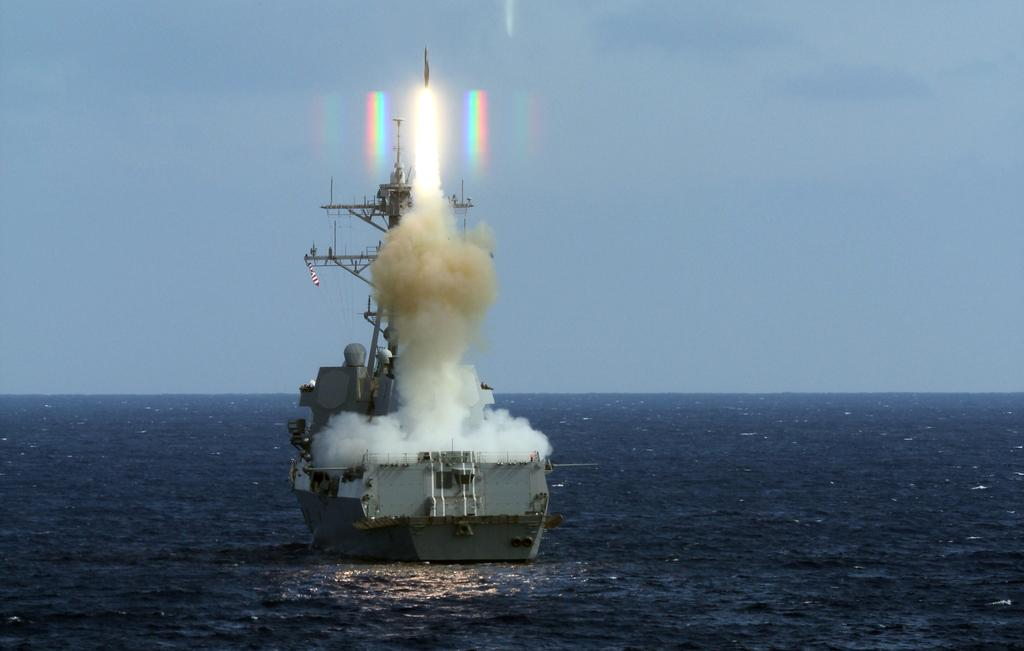What type of natural body of water is present in the image? There is an ocean in the picture. What is the color of the water in the ocean? The ocean has blue water. What is floating on the ocean in the image? There is a ship in the ocean. What features can be seen on the ship? The ship has poles and is producing smoke. What is visible in the background of the image? There is a sky visible in the background of the image. What type of education can be seen taking place on the ship in the image? There is no indication of education taking place on the ship in the image. What type of creature is swimming alongside the ship in the image? There is no creature swimming alongside the ship in the image. 